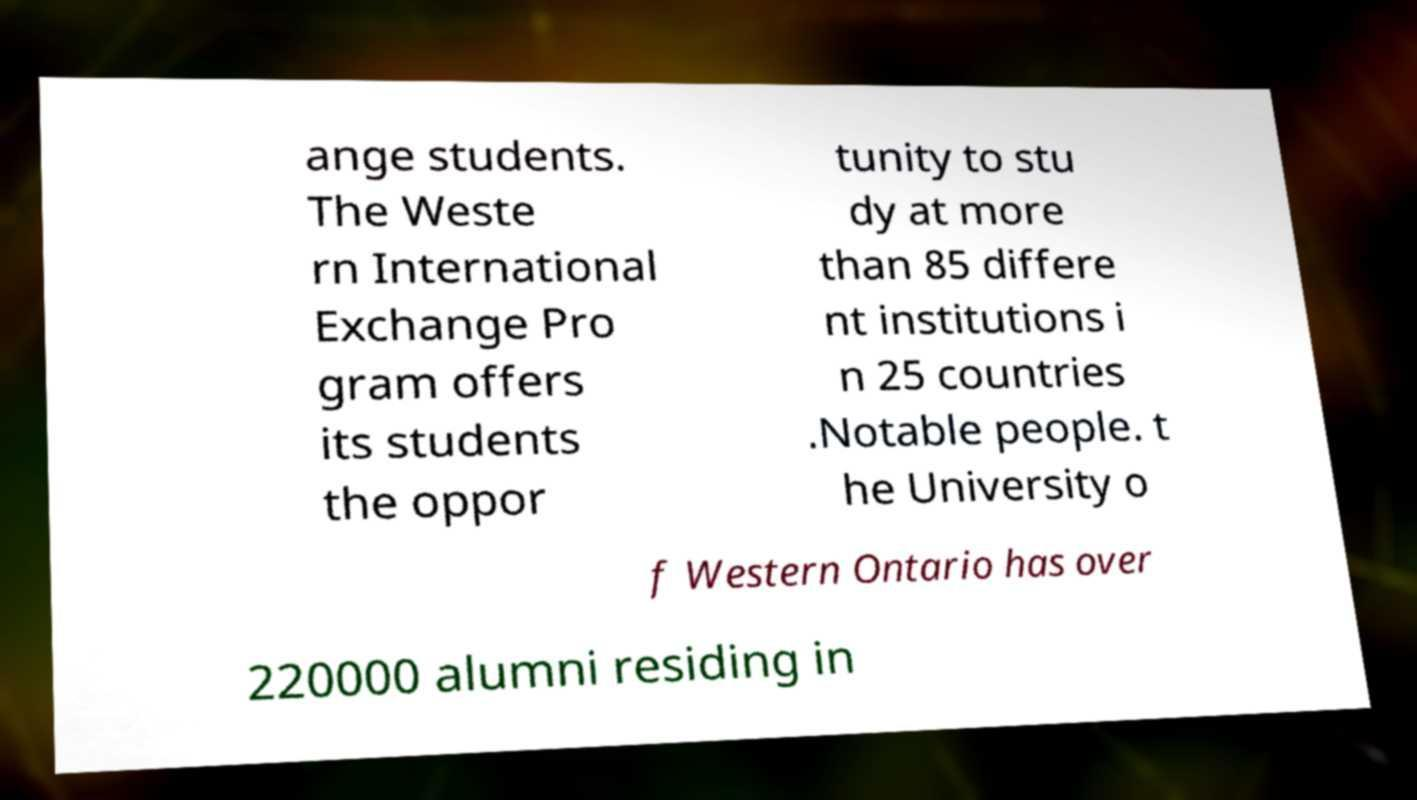I need the written content from this picture converted into text. Can you do that? ange students. The Weste rn International Exchange Pro gram offers its students the oppor tunity to stu dy at more than 85 differe nt institutions i n 25 countries .Notable people. t he University o f Western Ontario has over 220000 alumni residing in 